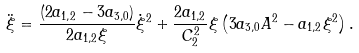<formula> <loc_0><loc_0><loc_500><loc_500>\ddot { \xi } = \frac { ( 2 a _ { 1 , 2 } - 3 a _ { 3 , 0 } ) } { 2 a _ { 1 , 2 } \xi } \dot { \xi } ^ { 2 } + \frac { 2 a _ { 1 , 2 } } { C _ { 2 } ^ { 2 } } \xi \left ( 3 a _ { 3 , 0 } A ^ { 2 } - a _ { 1 , 2 } \xi ^ { 2 } \right ) .</formula> 